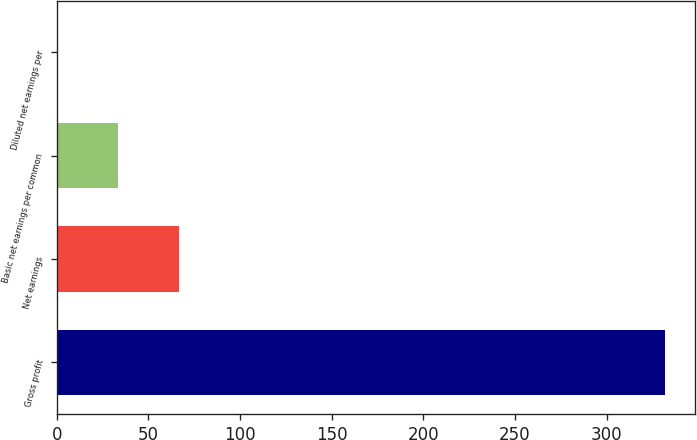Convert chart. <chart><loc_0><loc_0><loc_500><loc_500><bar_chart><fcel>Gross profit<fcel>Net earnings<fcel>Basic net earnings per common<fcel>Diluted net earnings per<nl><fcel>331.8<fcel>66.59<fcel>33.44<fcel>0.29<nl></chart> 